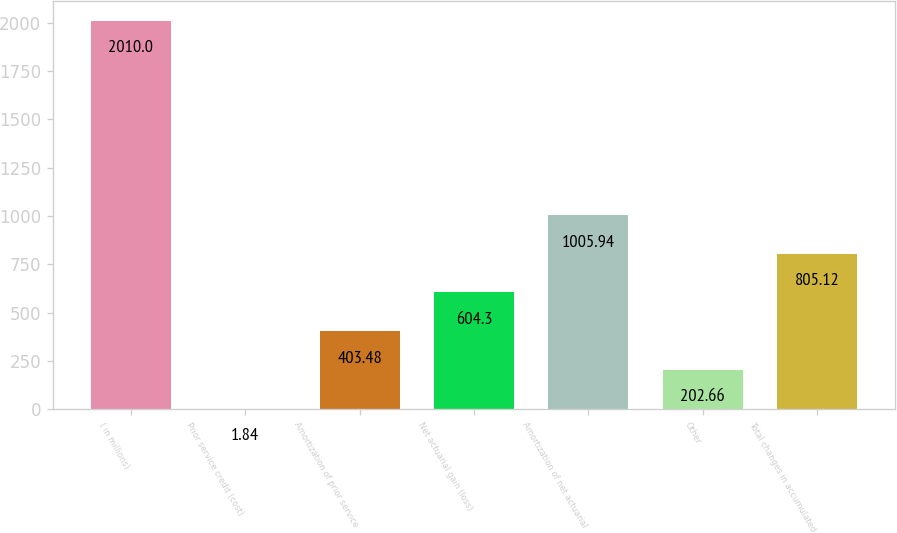<chart> <loc_0><loc_0><loc_500><loc_500><bar_chart><fcel>( in millions)<fcel>Prior service credit (cost)<fcel>Amortization of prior service<fcel>Net actuarial gain (loss)<fcel>Amortization of net actuarial<fcel>Other<fcel>Total changes in accumulated<nl><fcel>2010<fcel>1.84<fcel>403.48<fcel>604.3<fcel>1005.94<fcel>202.66<fcel>805.12<nl></chart> 